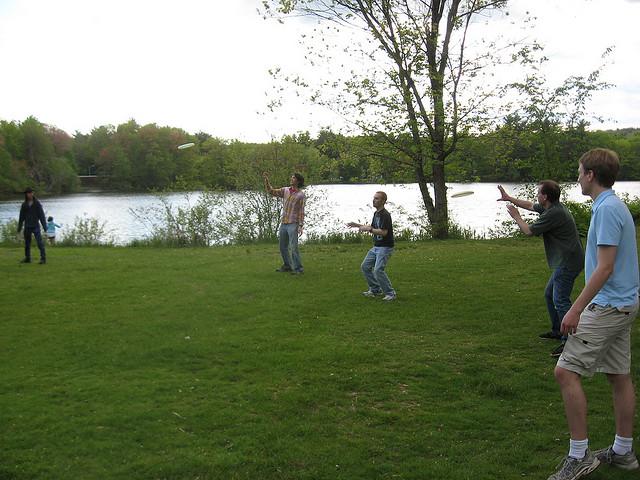Is it a sunny day?
Write a very short answer. Yes. How many men do you see?
Give a very brief answer. 5. Is there a picnic table in the picture?
Concise answer only. No. Is there someone to catch the Frisbee?
Keep it brief. Yes. How many people are wearing pants?
Quick response, please. 4. Where are the two men headed towards?
Give a very brief answer. Frisbee. What game are they playing?
Short answer required. Frisbee. What is on the air?
Keep it brief. Frisbee. What are the men playing?
Quick response, please. Frisbee. What two surfaces can be seen?
Answer briefly. Water and grass. Are they smiling?
Write a very short answer. Yes. What are they standing around?
Concise answer only. Lake. How many people are standing close to the water?
Write a very short answer. 1. 